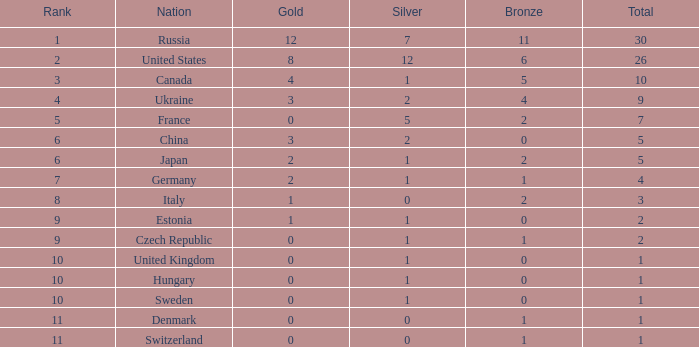What is the maximum silver with gold more than 4, in a us nation, and a total surpassing 26? None. 